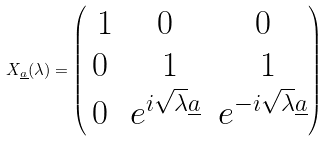Convert formula to latex. <formula><loc_0><loc_0><loc_500><loc_500>X _ { \underline { a } } ( \lambda ) = \begin{pmatrix} \ 1 & 0 & 0 \\ 0 & \ 1 & \ 1 \\ 0 & e ^ { i \sqrt { \lambda } \underline { a } } & e ^ { - i \sqrt { \lambda } \underline { a } } \end{pmatrix}</formula> 